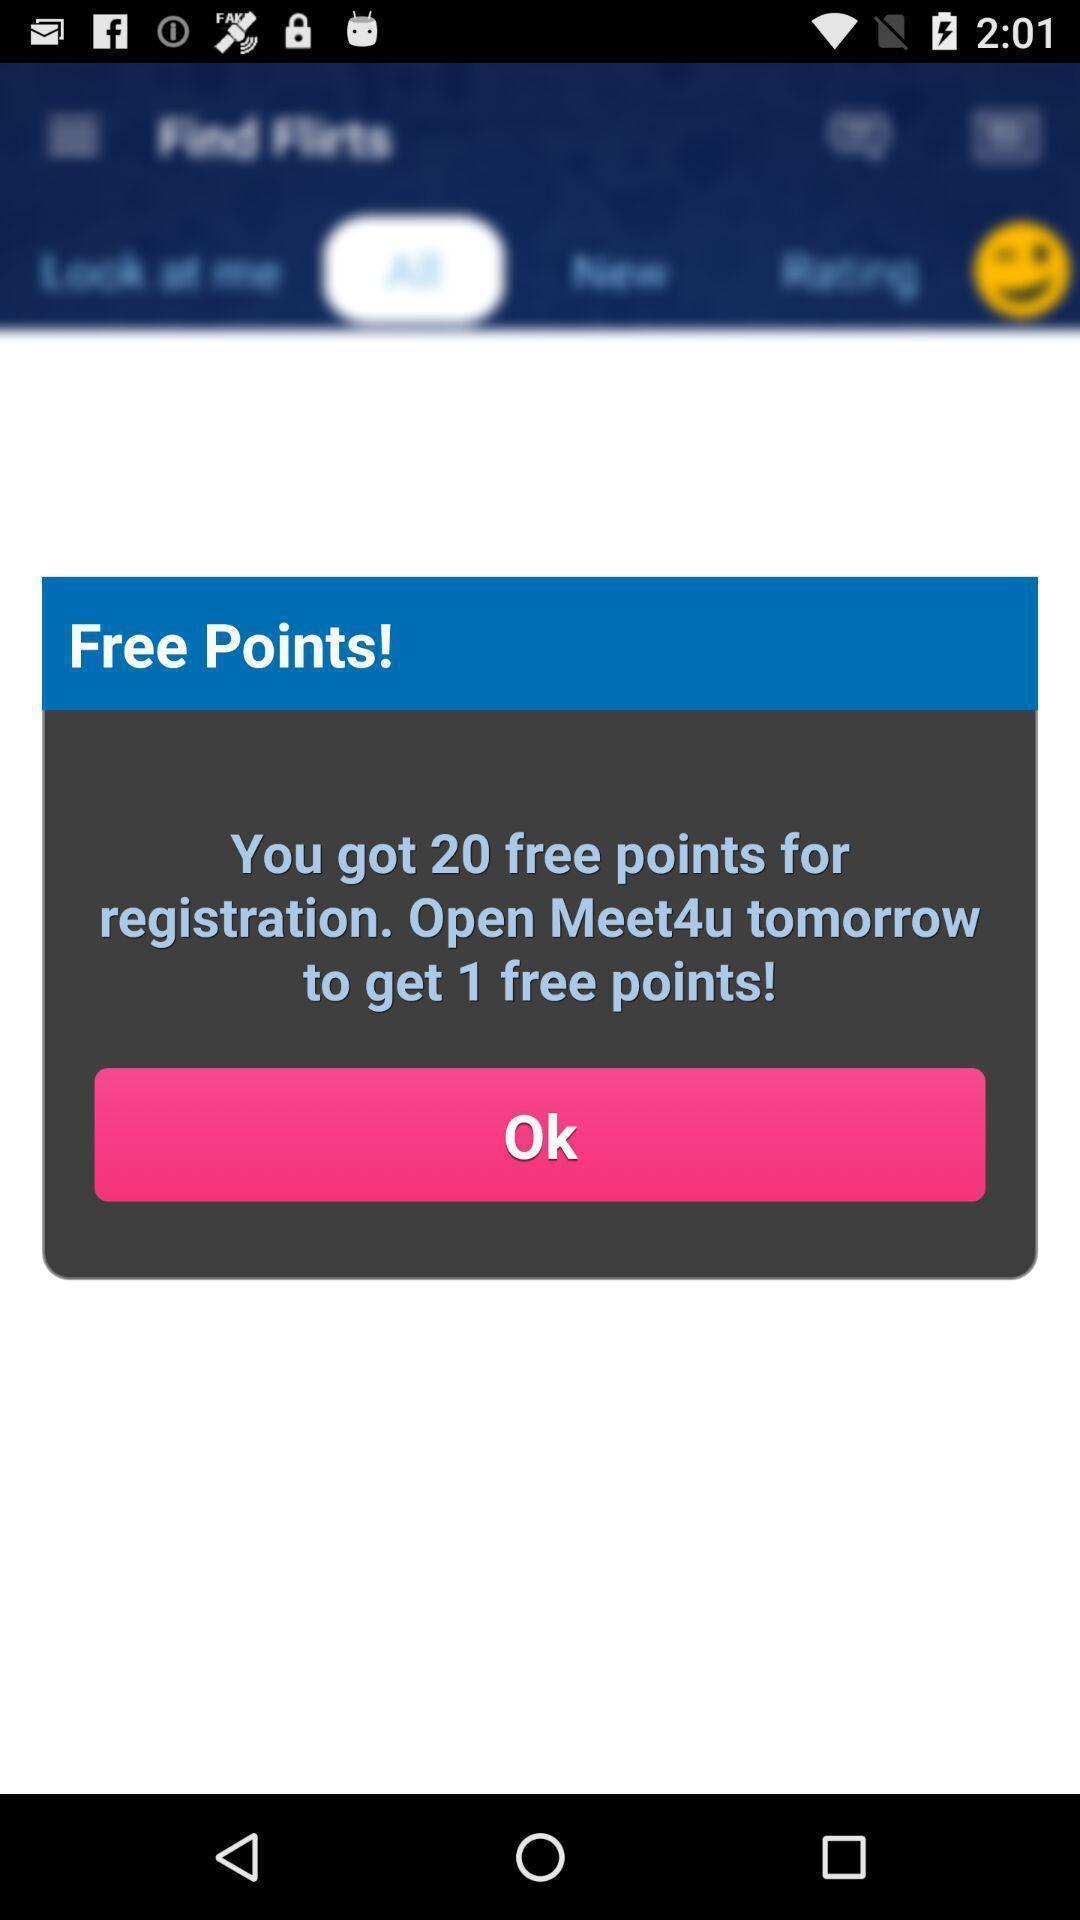Describe this image in words. Pop-up displaying free points on registration. 